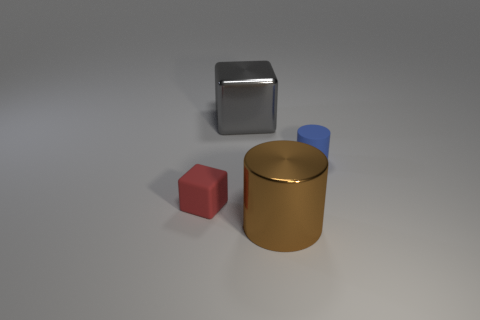Add 3 red metal spheres. How many objects exist? 7 Subtract all large things. Subtract all tiny red rubber objects. How many objects are left? 1 Add 2 blue objects. How many blue objects are left? 3 Add 4 big shiny objects. How many big shiny objects exist? 6 Subtract 0 blue balls. How many objects are left? 4 